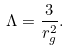<formula> <loc_0><loc_0><loc_500><loc_500>\Lambda = \frac { 3 } { r _ { g } ^ { 2 } } .</formula> 